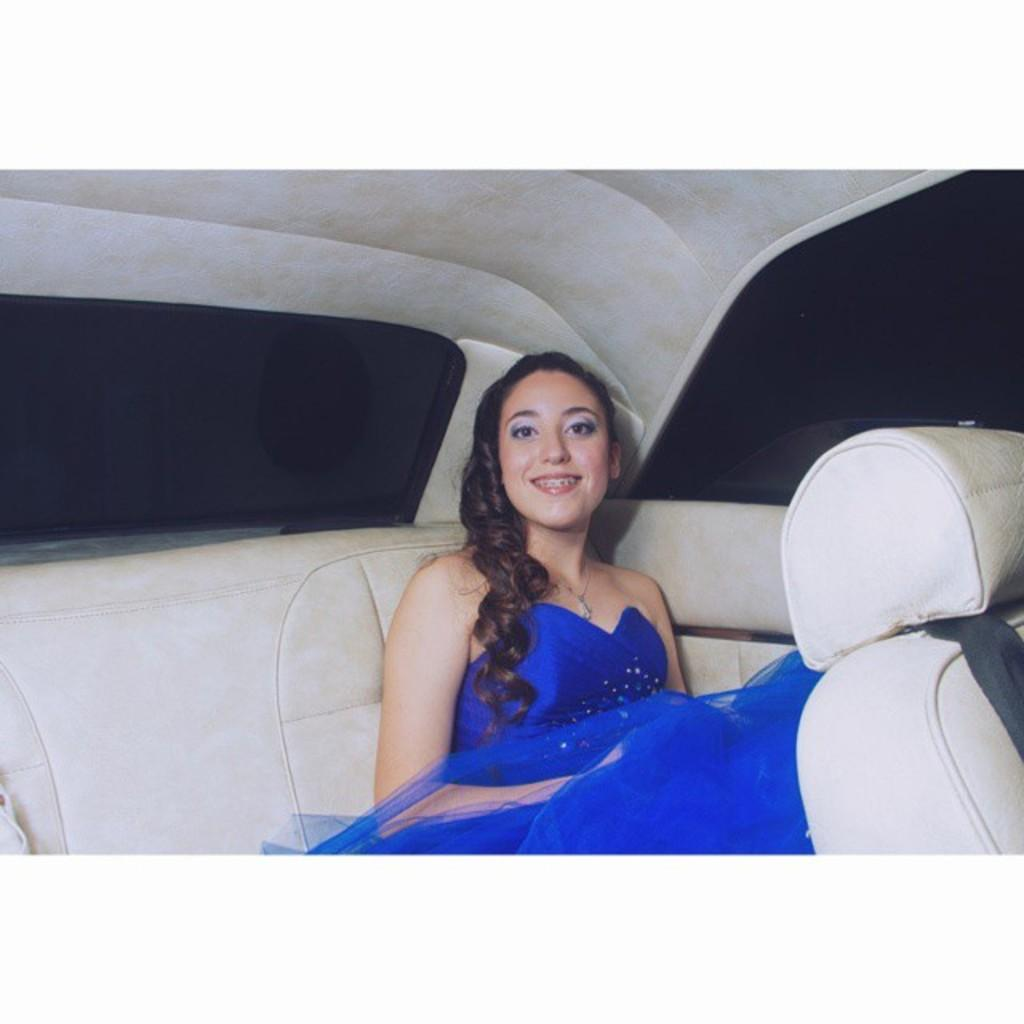Who is the main subject in the image? There is a woman in the image. What is the woman wearing? The woman is wearing a blue dress. What is the woman doing in the image? The woman is sitting in a car. What is the woman's facial expression in the image? The woman is smiling. What type of circle can be seen in the image? There is no circle present in the image. Is the woman in the image regretting her decision to sit in the car? The image does not provide any information about the woman's regrets or decisions. 